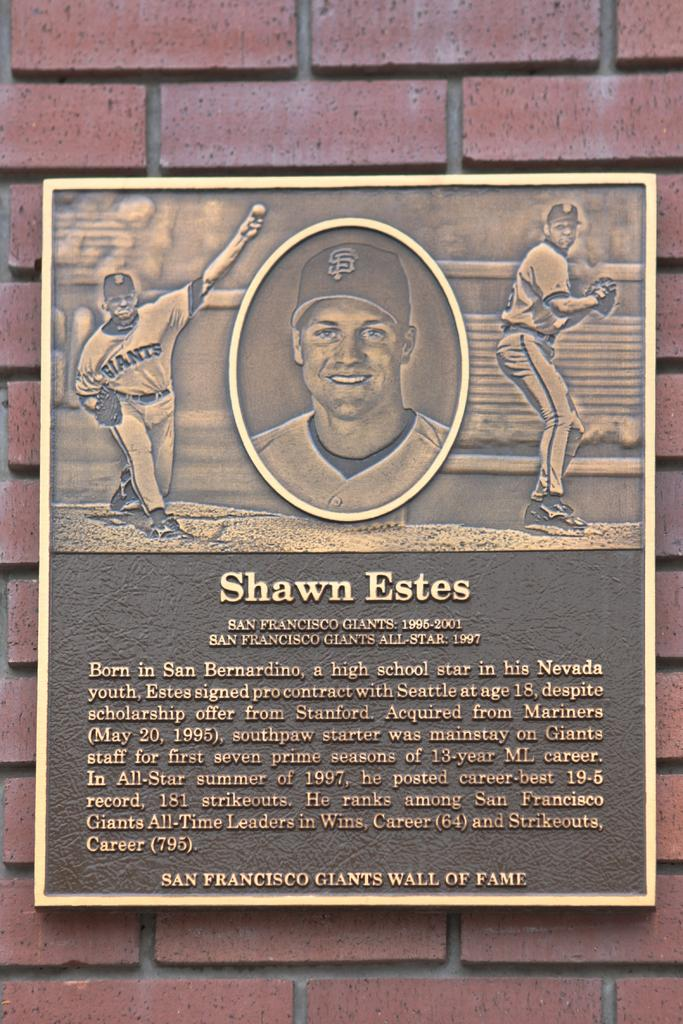<image>
Create a compact narrative representing the image presented. a bronzed plaque honoring Shawn Estes the baseball player 